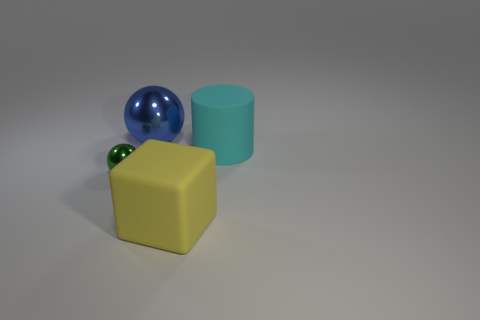Add 4 large cyan things. How many objects exist? 8 Subtract all blocks. How many objects are left? 3 Add 1 large blue shiny cubes. How many large blue shiny cubes exist? 1 Subtract 0 yellow balls. How many objects are left? 4 Subtract all tiny purple matte cylinders. Subtract all blue metal spheres. How many objects are left? 3 Add 3 yellow things. How many yellow things are left? 4 